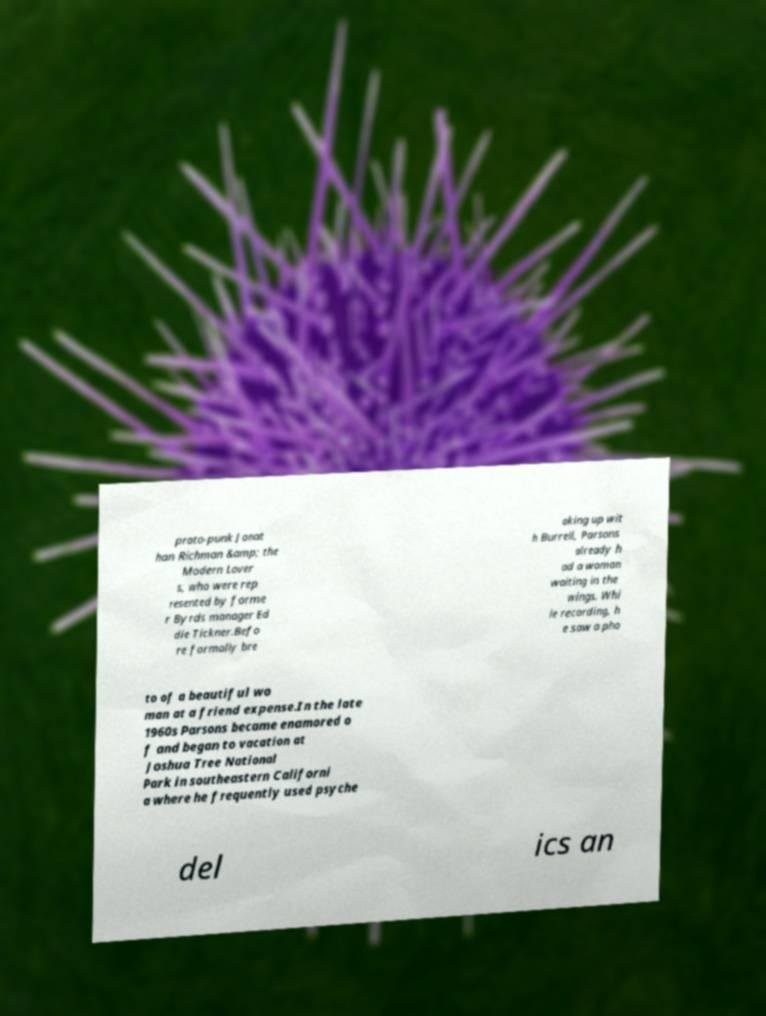Could you assist in decoding the text presented in this image and type it out clearly? proto-punk Jonat han Richman &amp; the Modern Lover s, who were rep resented by forme r Byrds manager Ed die Tickner.Befo re formally bre aking up wit h Burrell, Parsons already h ad a woman waiting in the wings. Whi le recording, h e saw a pho to of a beautiful wo man at a friend expense.In the late 1960s Parsons became enamored o f and began to vacation at Joshua Tree National Park in southeastern Californi a where he frequently used psyche del ics an 